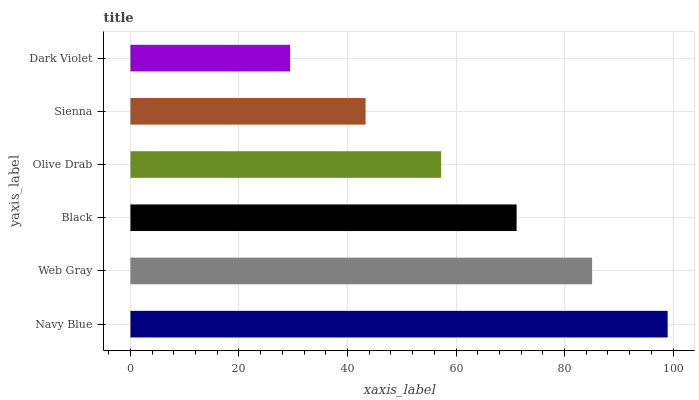Is Dark Violet the minimum?
Answer yes or no. Yes. Is Navy Blue the maximum?
Answer yes or no. Yes. Is Web Gray the minimum?
Answer yes or no. No. Is Web Gray the maximum?
Answer yes or no. No. Is Navy Blue greater than Web Gray?
Answer yes or no. Yes. Is Web Gray less than Navy Blue?
Answer yes or no. Yes. Is Web Gray greater than Navy Blue?
Answer yes or no. No. Is Navy Blue less than Web Gray?
Answer yes or no. No. Is Black the high median?
Answer yes or no. Yes. Is Olive Drab the low median?
Answer yes or no. Yes. Is Sienna the high median?
Answer yes or no. No. Is Sienna the low median?
Answer yes or no. No. 